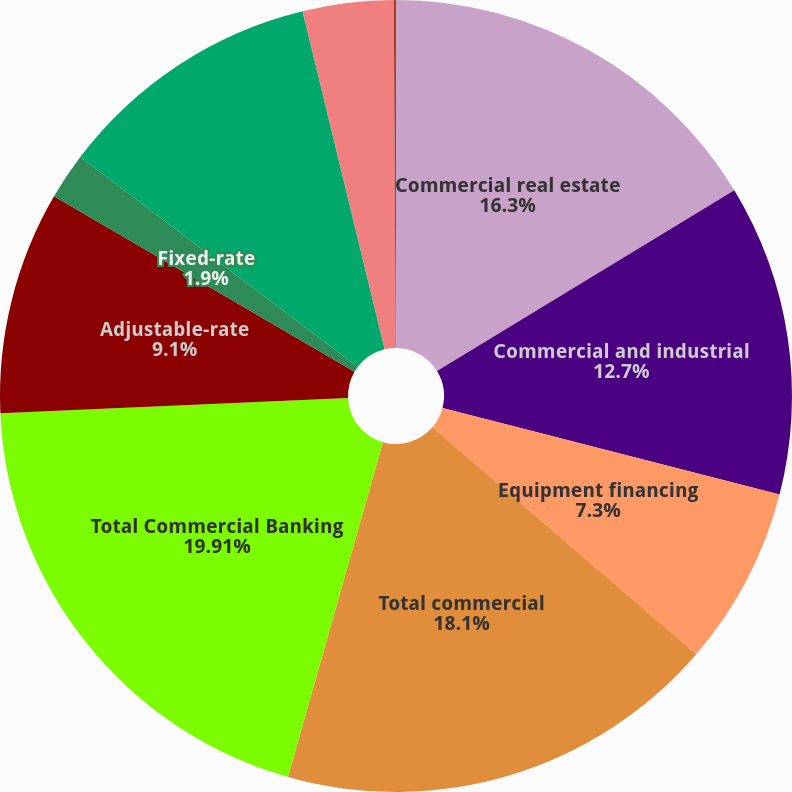Convert chart. <chart><loc_0><loc_0><loc_500><loc_500><pie_chart><fcel>Commercial real estate<fcel>Commercial and industrial<fcel>Equipment financing<fcel>Total commercial<fcel>Total Commercial Banking<fcel>Adjustable-rate<fcel>Fixed-rate<fcel>Total residential mortgage<fcel>Home equity<fcel>Other consumer<nl><fcel>16.3%<fcel>12.7%<fcel>7.3%<fcel>18.1%<fcel>19.91%<fcel>9.1%<fcel>1.9%<fcel>10.9%<fcel>3.7%<fcel>0.09%<nl></chart> 